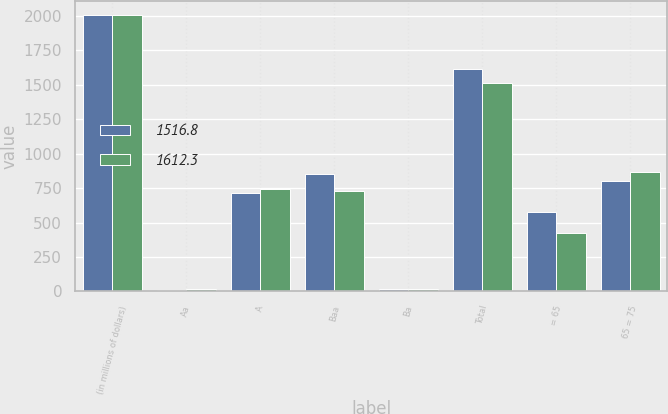Convert chart to OTSL. <chart><loc_0><loc_0><loc_500><loc_500><stacked_bar_chart><ecel><fcel>(in millions of dollars)<fcel>Aa<fcel>A<fcel>Baa<fcel>Ba<fcel>Total<fcel>= 65<fcel>65 = 75<nl><fcel>1516.8<fcel>2011<fcel>10.9<fcel>712.6<fcel>855<fcel>20.7<fcel>1612.3<fcel>578.4<fcel>802.3<nl><fcel>1612.3<fcel>2010<fcel>19<fcel>744.4<fcel>732.9<fcel>20.5<fcel>1516.8<fcel>425.3<fcel>869.2<nl></chart> 